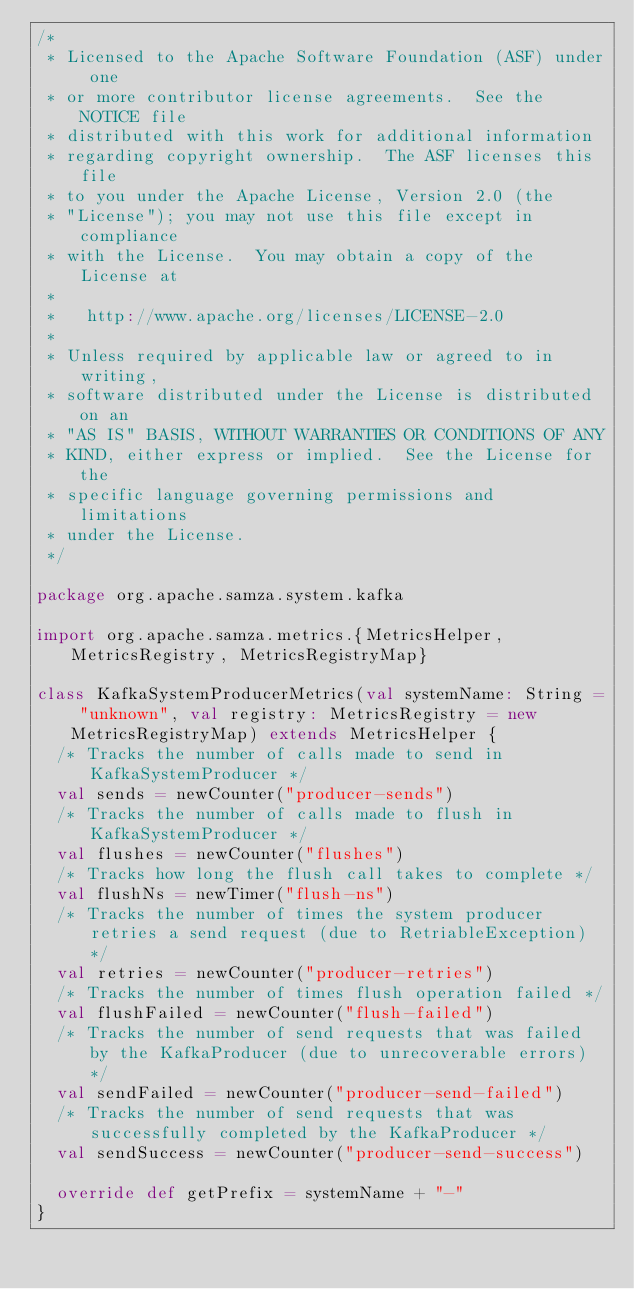<code> <loc_0><loc_0><loc_500><loc_500><_Scala_>/*
 * Licensed to the Apache Software Foundation (ASF) under one
 * or more contributor license agreements.  See the NOTICE file
 * distributed with this work for additional information
 * regarding copyright ownership.  The ASF licenses this file
 * to you under the Apache License, Version 2.0 (the
 * "License"); you may not use this file except in compliance
 * with the License.  You may obtain a copy of the License at
 *
 *   http://www.apache.org/licenses/LICENSE-2.0
 *
 * Unless required by applicable law or agreed to in writing,
 * software distributed under the License is distributed on an
 * "AS IS" BASIS, WITHOUT WARRANTIES OR CONDITIONS OF ANY
 * KIND, either express or implied.  See the License for the
 * specific language governing permissions and limitations
 * under the License.
 */

package org.apache.samza.system.kafka

import org.apache.samza.metrics.{MetricsHelper, MetricsRegistry, MetricsRegistryMap}

class KafkaSystemProducerMetrics(val systemName: String = "unknown", val registry: MetricsRegistry = new MetricsRegistryMap) extends MetricsHelper {
  /* Tracks the number of calls made to send in KafkaSystemProducer */
  val sends = newCounter("producer-sends")
  /* Tracks the number of calls made to flush in KafkaSystemProducer */
  val flushes = newCounter("flushes")
  /* Tracks how long the flush call takes to complete */
  val flushNs = newTimer("flush-ns")
  /* Tracks the number of times the system producer retries a send request (due to RetriableException) */
  val retries = newCounter("producer-retries")
  /* Tracks the number of times flush operation failed */
  val flushFailed = newCounter("flush-failed")
  /* Tracks the number of send requests that was failed by the KafkaProducer (due to unrecoverable errors) */
  val sendFailed = newCounter("producer-send-failed")
  /* Tracks the number of send requests that was successfully completed by the KafkaProducer */
  val sendSuccess = newCounter("producer-send-success")

  override def getPrefix = systemName + "-"
}
</code> 